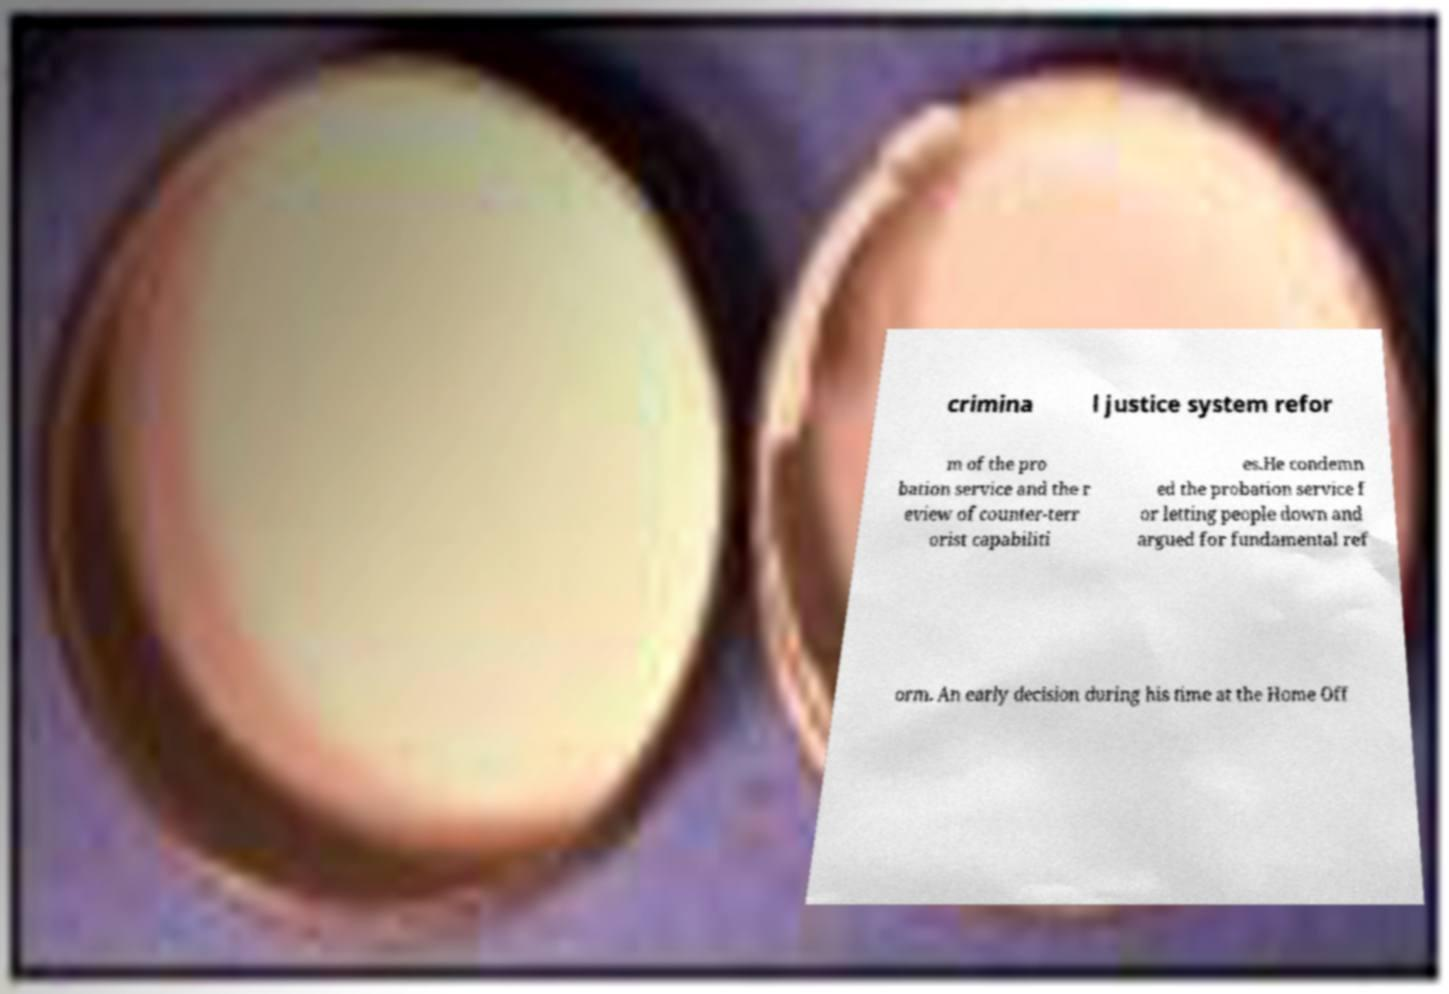Can you read and provide the text displayed in the image?This photo seems to have some interesting text. Can you extract and type it out for me? crimina l justice system refor m of the pro bation service and the r eview of counter-terr orist capabiliti es.He condemn ed the probation service f or letting people down and argued for fundamental ref orm. An early decision during his time at the Home Off 